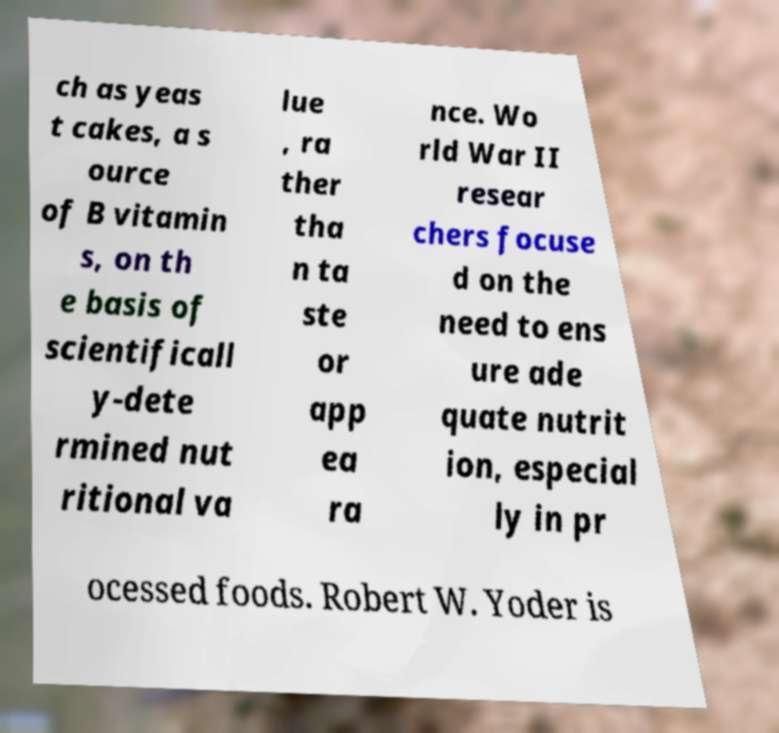Can you read and provide the text displayed in the image?This photo seems to have some interesting text. Can you extract and type it out for me? ch as yeas t cakes, a s ource of B vitamin s, on th e basis of scientificall y-dete rmined nut ritional va lue , ra ther tha n ta ste or app ea ra nce. Wo rld War II resear chers focuse d on the need to ens ure ade quate nutrit ion, especial ly in pr ocessed foods. Robert W. Yoder is 